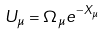<formula> <loc_0><loc_0><loc_500><loc_500>U _ { \mu } = \Omega _ { \mu } e ^ { - X _ { \mu } }</formula> 